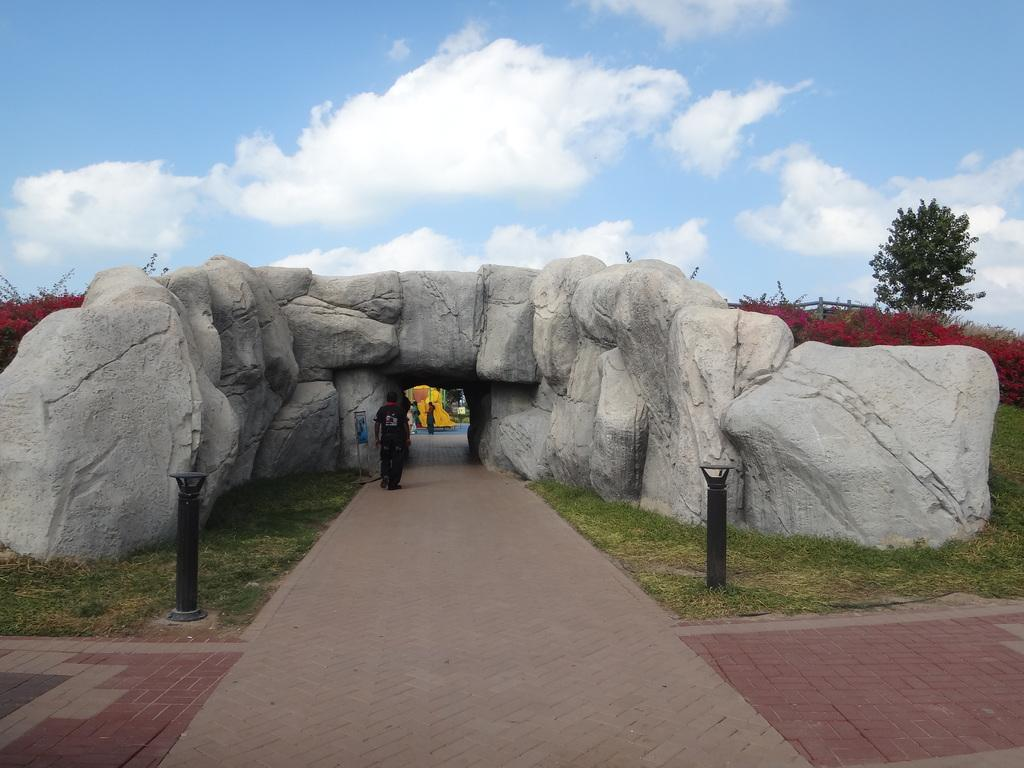What are the people in the image doing? The people in the image are standing on a path. What type of natural features can be seen in the image? Rocks and trees are visible in the image. What structures are present in the image? Poles are in the image. What can be seen in the background of the image? The sky with clouds is visible in the background of the image. What type of produce is being sold on the tray in the image? There is no tray or produce present in the image. What is the primary interest of the people in the image? The image does not provide information about the people's interests, as they are simply standing on a path. 